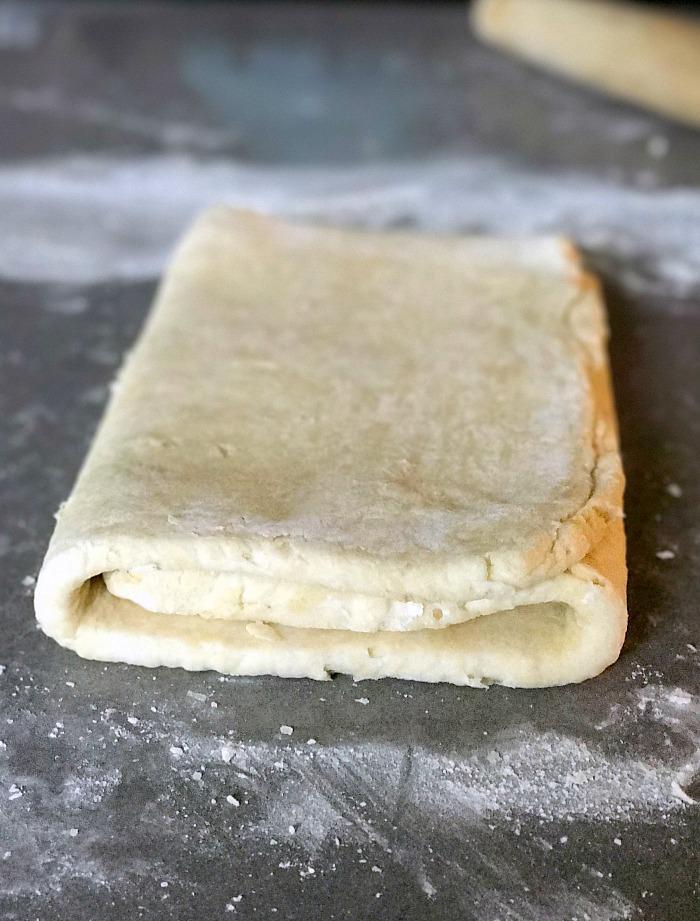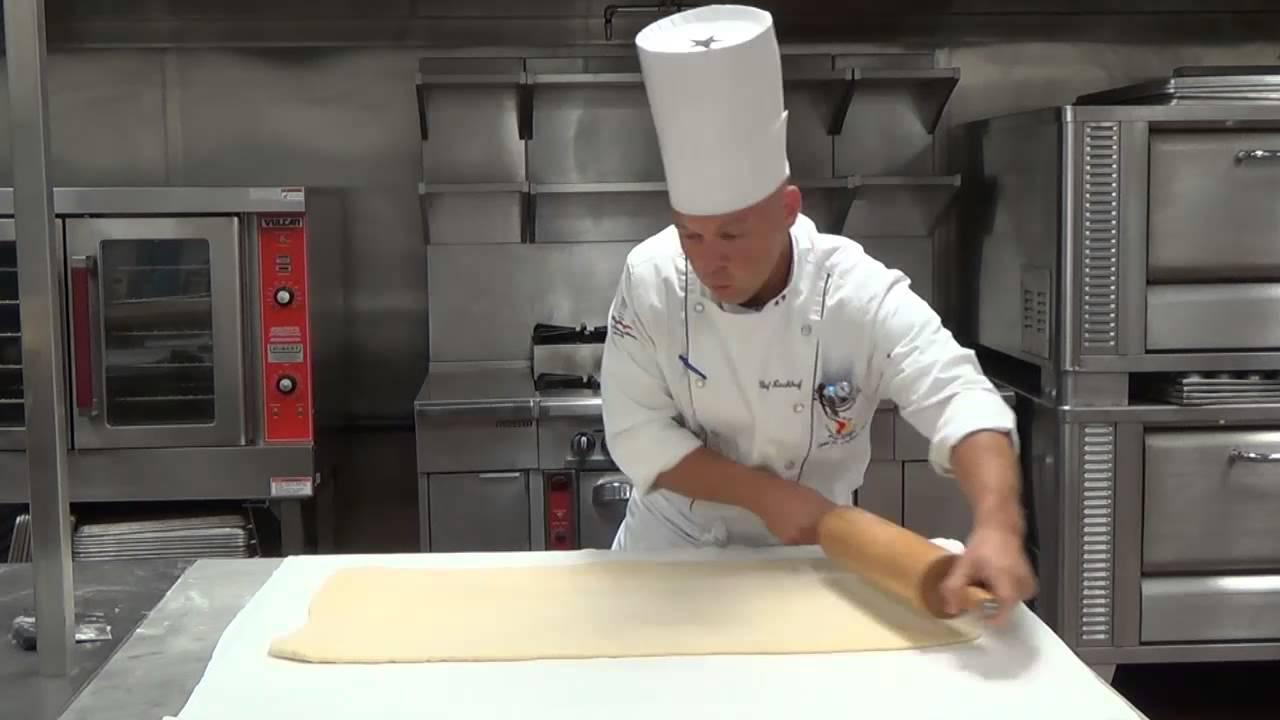The first image is the image on the left, the second image is the image on the right. For the images displayed, is the sentence "A single person is working with dough in the image on the left." factually correct? Answer yes or no. No. 